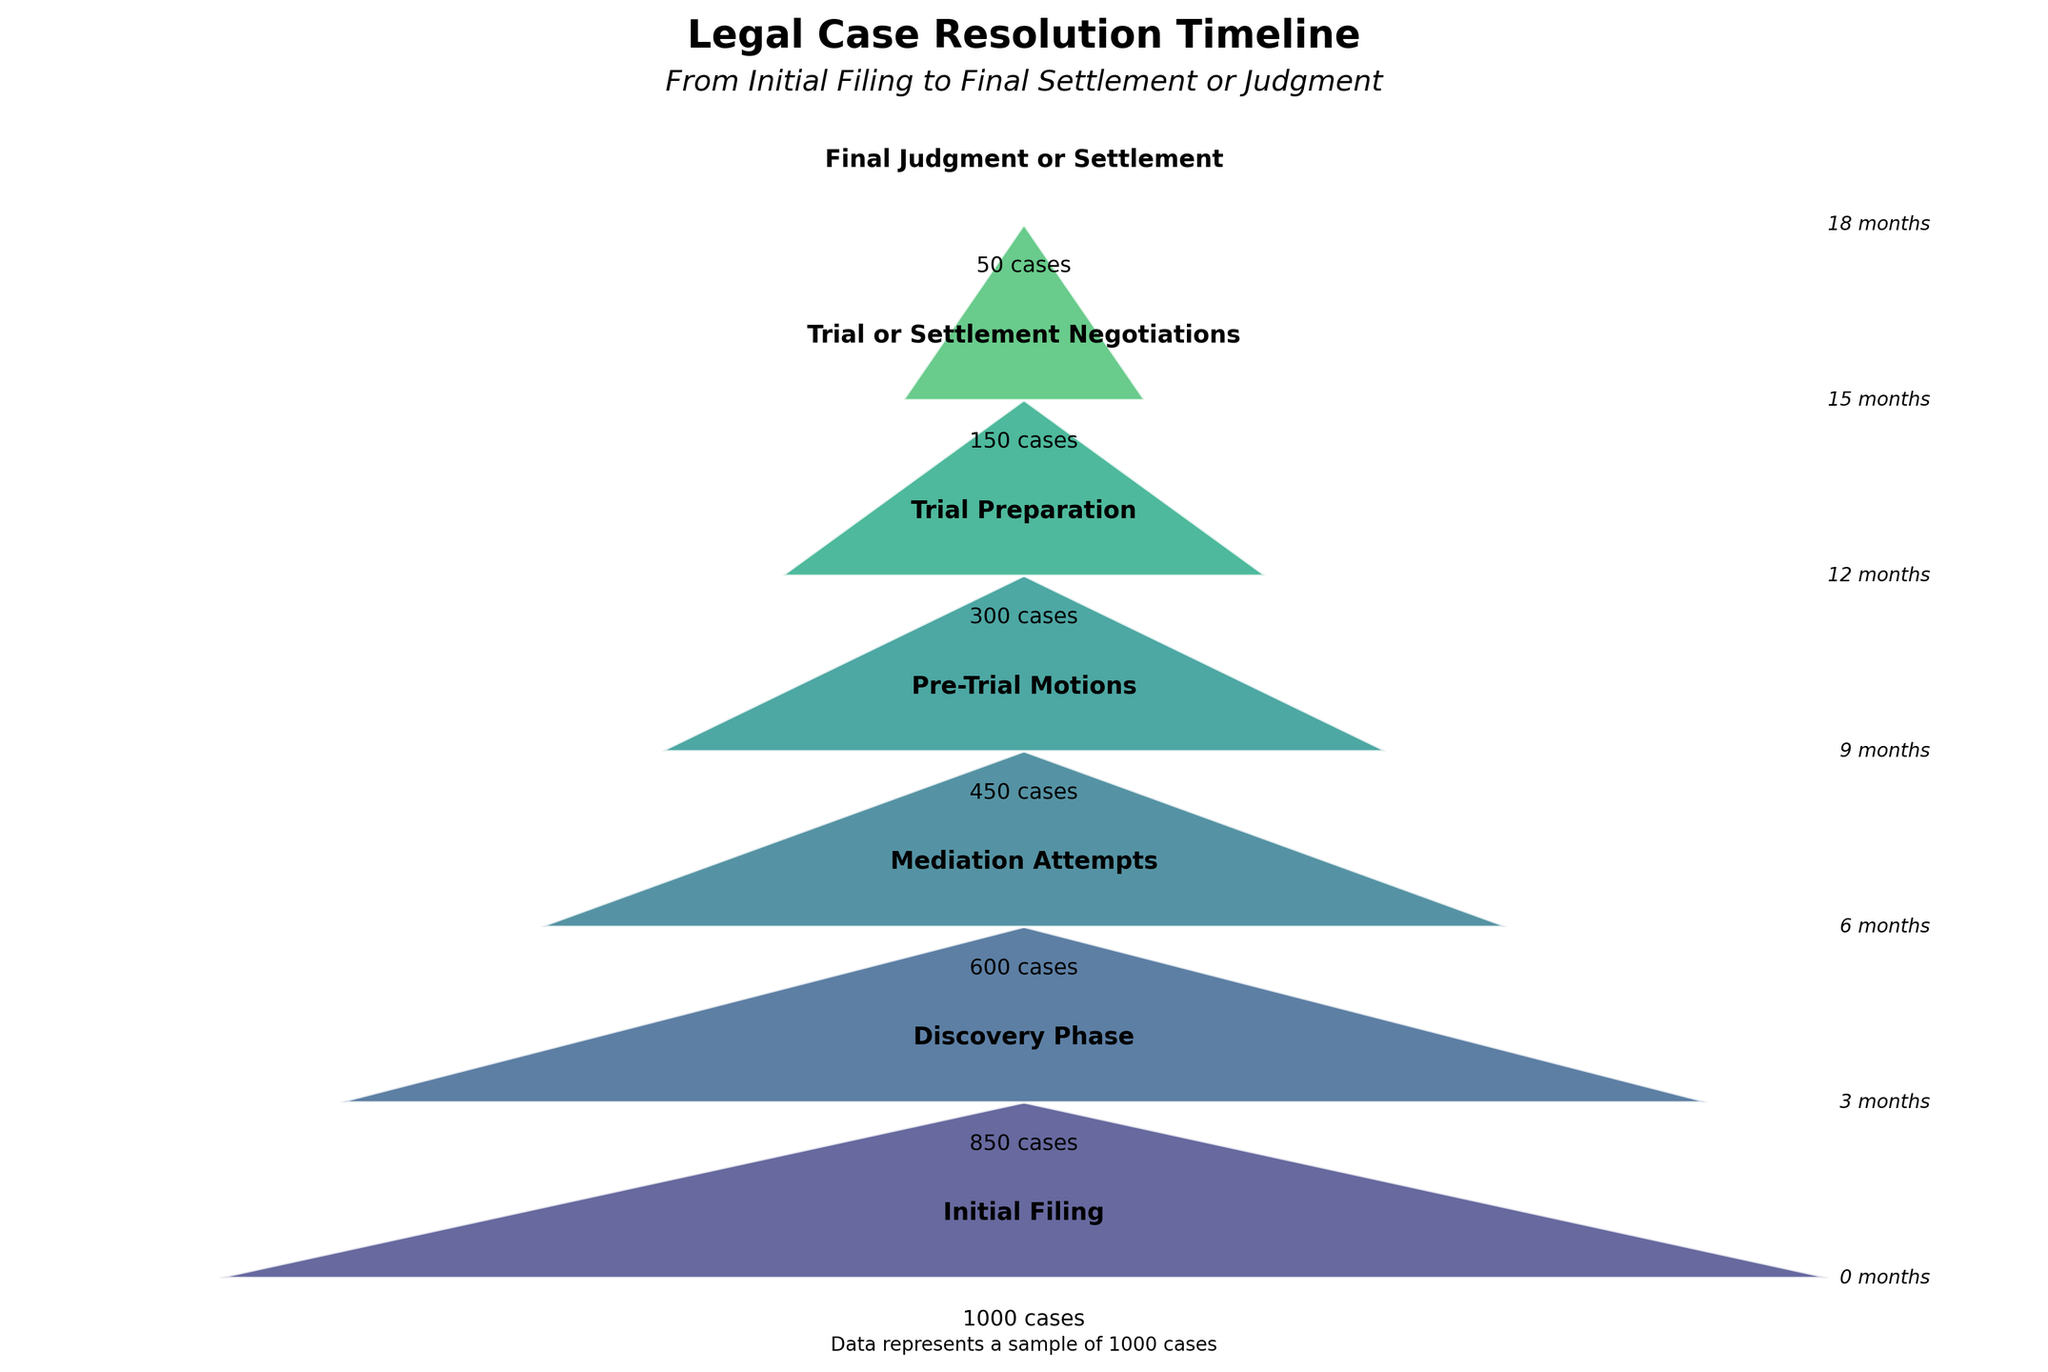How many stages are depicted in the Funnel Chart? The figure shows the journey from initial filing to final settlement or judgment. Counting each stage name listed from the top to the bottom of the chart gives the number of stages.
Answer: 7 What is the title of the Funnel Chart? The title is usually found at the top of the figure, clearly labeling what the chart is about.
Answer: Legal Case Resolution Timeline How does the number of cases remaining change from the Discovery Phase to the Mediation Attempts phase? The chart shows 850 cases remaining in the Discovery Phase and 600 cases in the Mediation Attempts phase. Subtracting these numbers shows the change. 850 - 600 = 250
Answer: 250 Which stage has the longest duration according to the funnel chart? This can be determined by looking at the "Time (Months)" label next to each stage. The stage with the highest number indicates the longest duration. The final stage, 'Final Judgment or Settlement', which is 18 months, has the longest duration.
Answer: Final Judgment or Settlement Compare the number of cases remaining at the Pre-Trial Motions phase with the number at the Trial Preparation phase. Which is greater and by how much? The chart indicates that there are 450 cases remaining at the Pre-Trial Motions phase and 300 at the Trial Preparation phase. Subtracting these two numbers gives the difference: 450 - 300 = 150.
Answer: Pre-Trial Motions; 150 What percentage of cases continue from the initial filing to the pre-trial motions? To find the percentage, divide the number of cases remaining at Pre-Trial Motions by the initial cases and then multiply by 100. (450 / 1000) * 100 = 45%
Answer: 45% How many months does it take for a case to reach the Mediation Attempts stage? The months associated with each stage are listed beside the stage names in the chart. For the Mediation Attempts stage, it mentions 6 months.
Answer: 6 months What is the reduction in cases from Trial Preparation to Final Judgment or Settlement? According to the chart, there are 300 cases at the Trial Preparation stage and 50 cases at the Final Judgment or Settlement stage. Subtracting these gives: 300 - 50 = 250.
Answer: 250 In which stage do half of the initial cases remain or fewer? To find the stage with half or fewer cases, look where the number of remaining cases is ≤ 500 (since 1000/2 = 500). The chart shows that this occurs at the Mediation Attempts stage with 600 cases and definitely at the Pre-Trial Motions stage with 450 cases.
Answer: Pre-Trial Motions What is the total time taken from Initial Filing to Final Judgment or Settlement? This requires summing the months from each stage listed in the figure. The final stage, Final Judgment or Settlement, is 18 months, which represents the total timeline from the initial filing to the last stage.
Answer: 18 months 